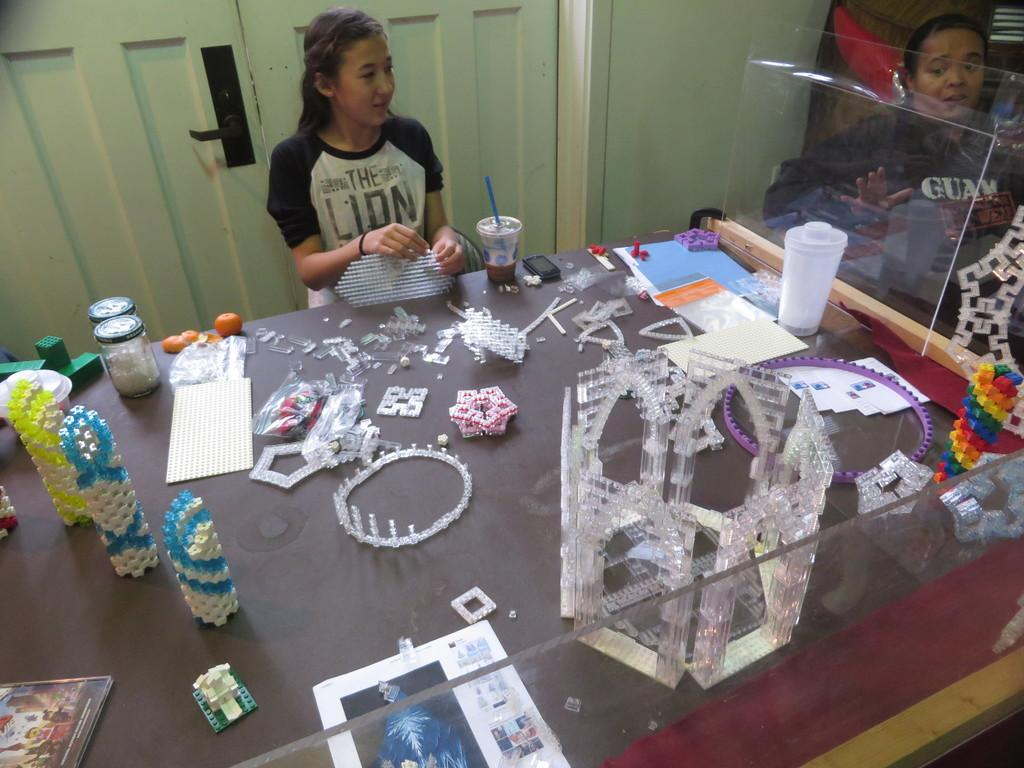What objects can be seen on the table in the image? There are cups, books, jars, puzzle games, and a phone on the table in the image. What type of activity might be associated with the puzzle games? The puzzle games might be associated with a leisure or problem-solving activity. How many women are present in the image? There are 2 women in the image. What is visible in the background of the image? There is a door visible in the background. What is the name of the baby born in the image? There is no baby or birth event depicted in the image. How many twists are visible in the puzzle games on the table? The puzzle games do not have twists; they are likely flat or three-dimensional objects. 